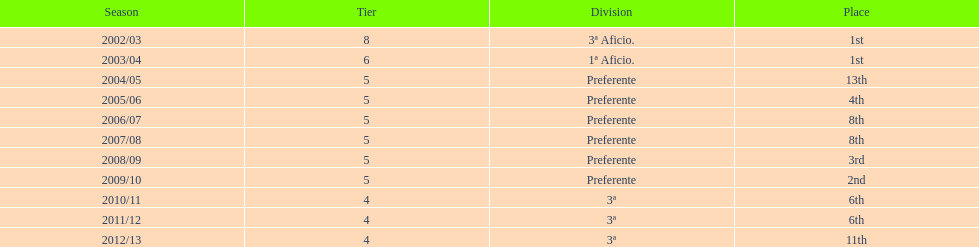How many times did internacional de madrid cf end the season at the top of their division? 2. 